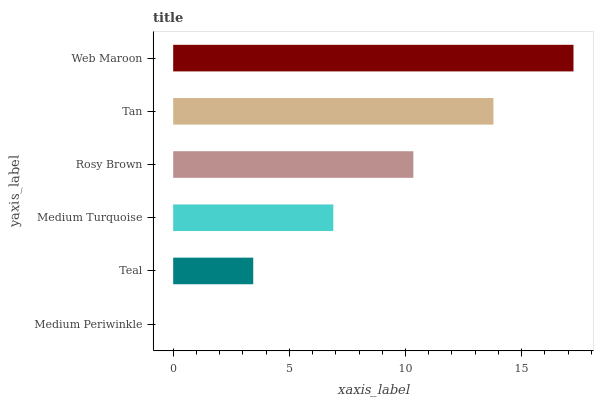Is Medium Periwinkle the minimum?
Answer yes or no. Yes. Is Web Maroon the maximum?
Answer yes or no. Yes. Is Teal the minimum?
Answer yes or no. No. Is Teal the maximum?
Answer yes or no. No. Is Teal greater than Medium Periwinkle?
Answer yes or no. Yes. Is Medium Periwinkle less than Teal?
Answer yes or no. Yes. Is Medium Periwinkle greater than Teal?
Answer yes or no. No. Is Teal less than Medium Periwinkle?
Answer yes or no. No. Is Rosy Brown the high median?
Answer yes or no. Yes. Is Medium Turquoise the low median?
Answer yes or no. Yes. Is Medium Periwinkle the high median?
Answer yes or no. No. Is Web Maroon the low median?
Answer yes or no. No. 